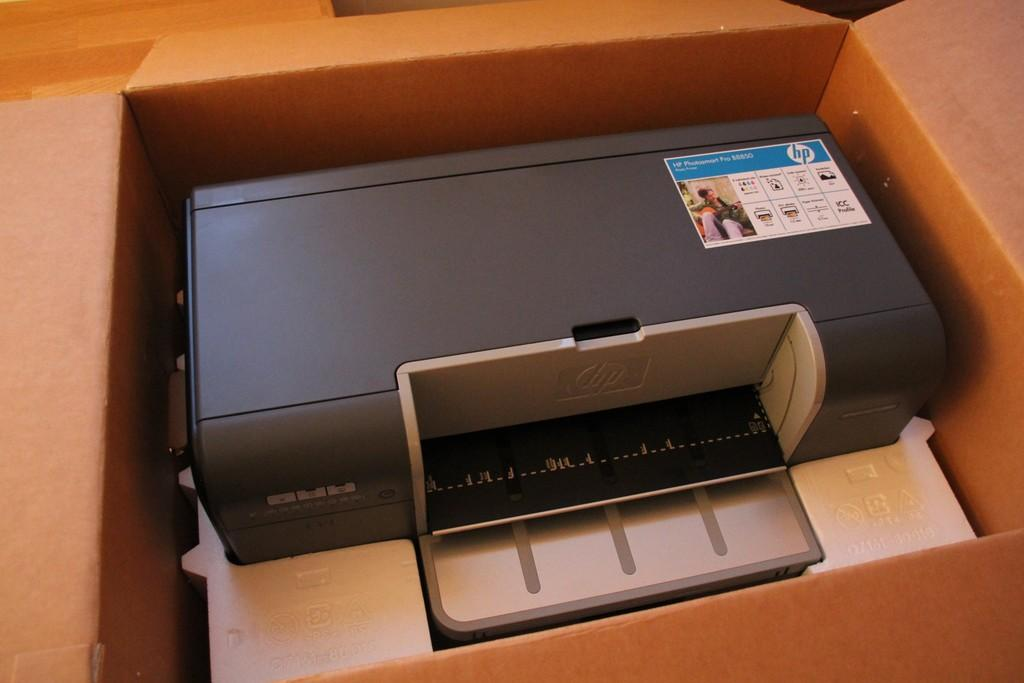<image>
Give a short and clear explanation of the subsequent image. The HP photo printer is compact and high quality. 